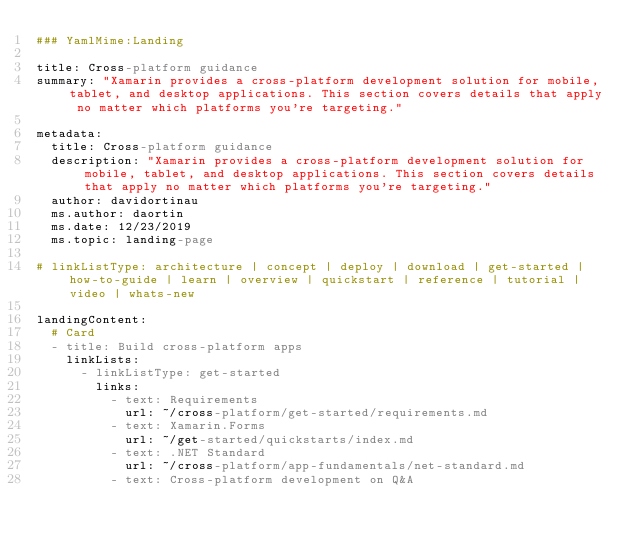<code> <loc_0><loc_0><loc_500><loc_500><_YAML_>### YamlMime:Landing

title: Cross-platform guidance
summary: "Xamarin provides a cross-platform development solution for mobile, tablet, and desktop applications. This section covers details that apply no matter which platforms you're targeting."

metadata:
  title: Cross-platform guidance
  description: "Xamarin provides a cross-platform development solution for mobile, tablet, and desktop applications. This section covers details that apply no matter which platforms you're targeting."
  author: davidortinau
  ms.author: daortin
  ms.date: 12/23/2019
  ms.topic: landing-page

# linkListType: architecture | concept | deploy | download | get-started | how-to-guide | learn | overview | quickstart | reference | tutorial | video | whats-new

landingContent:
  # Card
  - title: Build cross-platform apps
    linkLists:
      - linkListType: get-started
        links:
          - text: Requirements
            url: ~/cross-platform/get-started/requirements.md
          - text: Xamarin.Forms
            url: ~/get-started/quickstarts/index.md
          - text: .NET Standard
            url: ~/cross-platform/app-fundamentals/net-standard.md
          - text: Cross-platform development on Q&A</code> 